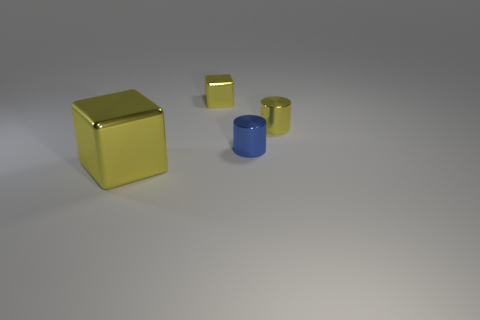There is a yellow cylinder that is made of the same material as the blue thing; what size is it? The yellow cylinder appears to be smaller in size compared to the blue cylinder; it is roughly half the height and has a similar diameter, based on the perspective in the image. 